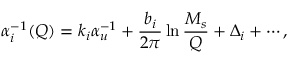Convert formula to latex. <formula><loc_0><loc_0><loc_500><loc_500>\alpha _ { i } ^ { - 1 } ( Q ) = k _ { i } \alpha _ { u } ^ { - 1 } + \frac { b _ { i } } { 2 \pi } \ln \frac { M _ { s } } { Q } + \Delta _ { i } + \cdots ,</formula> 